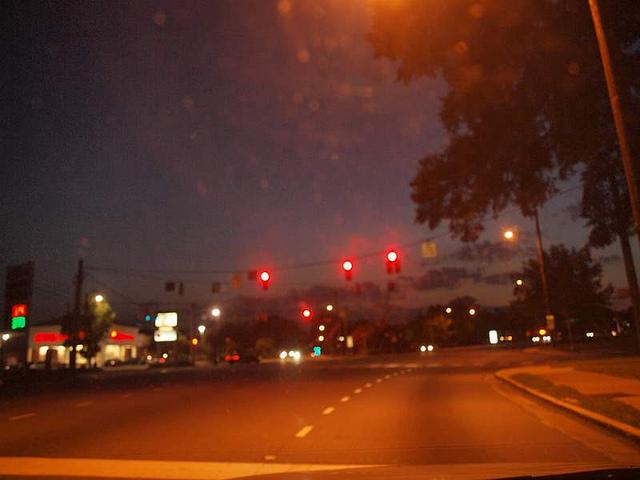What color are the street markings?
Give a very brief answer. Red. What is this road filled with?
Short answer required. Nothing. Are all of the traffic lights showing red?
Concise answer only. Yes. Why are the lights blurred?
Be succinct. Photo quality. What color is the traffic light showing?
Concise answer only. Red. What color are the lights?
Keep it brief. Red. Is it a nice night out?
Answer briefly. Yes. How many red traffic lights are visible?
Short answer required. 4. Are the streetlights on?
Concise answer only. Yes. 